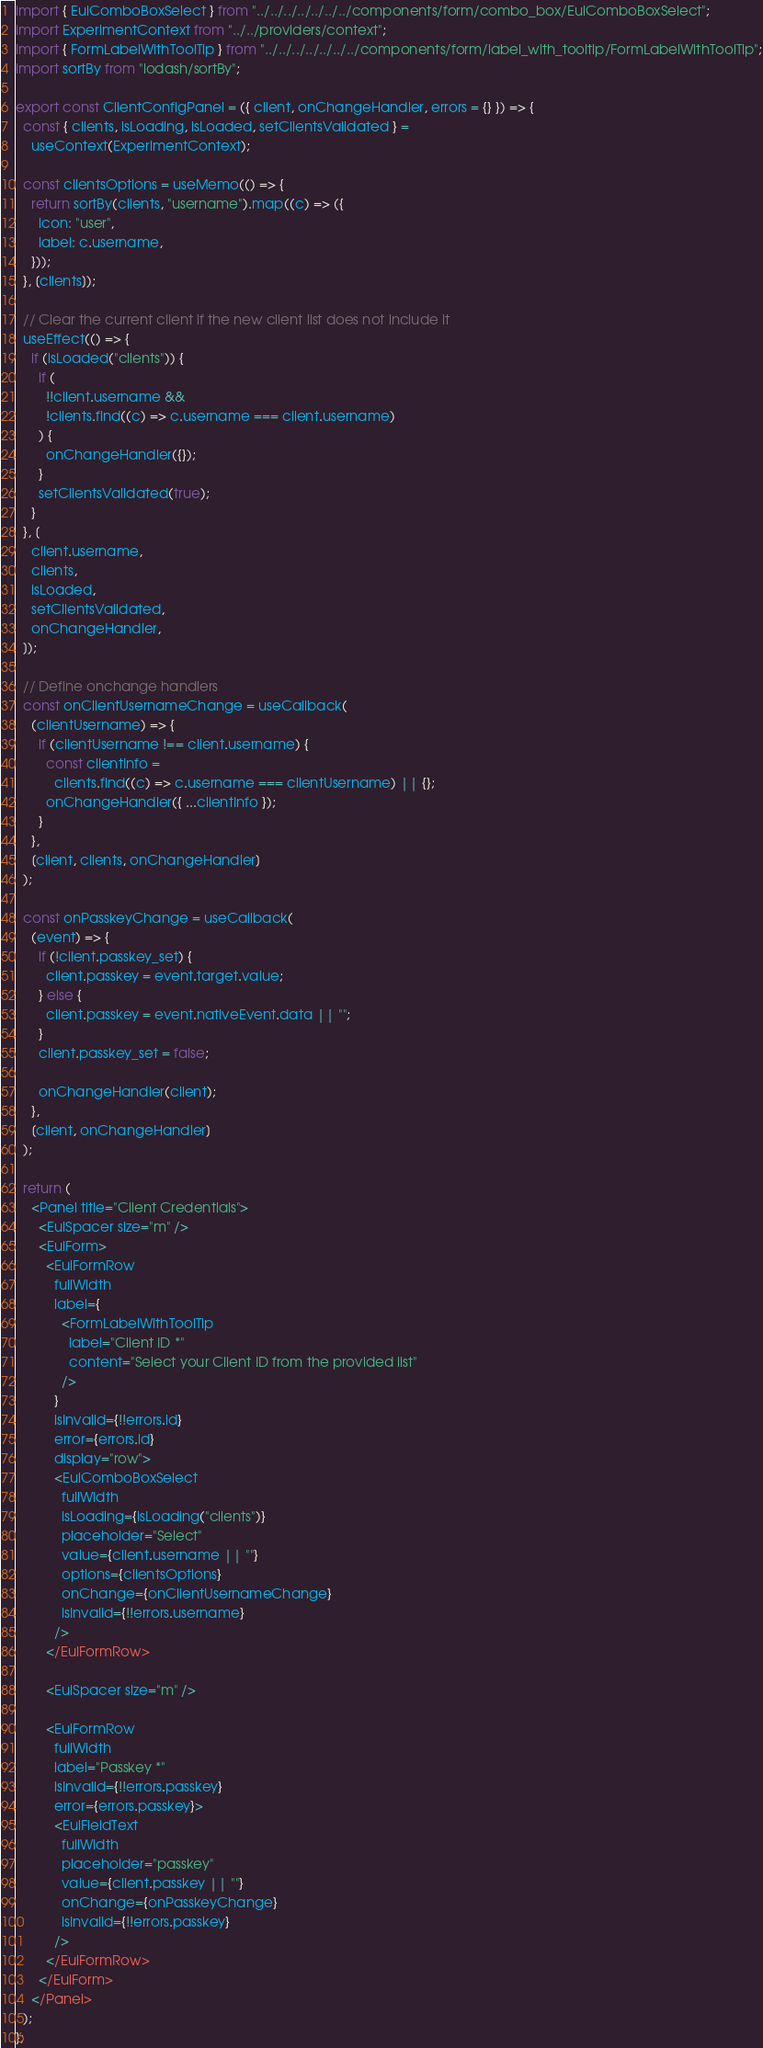<code> <loc_0><loc_0><loc_500><loc_500><_JavaScript_>import { EuiComboBoxSelect } from "../../../../../../../components/form/combo_box/EuiComboBoxSelect";
import ExperimentContext from "../../providers/context";
import { FormLabelWithToolTip } from "../../../../../../../components/form/label_with_tooltip/FormLabelWithToolTip";
import sortBy from "lodash/sortBy";

export const ClientConfigPanel = ({ client, onChangeHandler, errors = {} }) => {
  const { clients, isLoading, isLoaded, setClientsValidated } =
    useContext(ExperimentContext);

  const clientsOptions = useMemo(() => {
    return sortBy(clients, "username").map((c) => ({
      icon: "user",
      label: c.username,
    }));
  }, [clients]);

  // Clear the current client if the new client list does not include it
  useEffect(() => {
    if (isLoaded("clients")) {
      if (
        !!client.username &&
        !clients.find((c) => c.username === client.username)
      ) {
        onChangeHandler({});
      }
      setClientsValidated(true);
    }
  }, [
    client.username,
    clients,
    isLoaded,
    setClientsValidated,
    onChangeHandler,
  ]);

  // Define onchange handlers
  const onClientUsernameChange = useCallback(
    (clientUsername) => {
      if (clientUsername !== client.username) {
        const clientInfo =
          clients.find((c) => c.username === clientUsername) || {};
        onChangeHandler({ ...clientInfo });
      }
    },
    [client, clients, onChangeHandler]
  );

  const onPasskeyChange = useCallback(
    (event) => {
      if (!client.passkey_set) {
        client.passkey = event.target.value;
      } else {
        client.passkey = event.nativeEvent.data || "";
      }
      client.passkey_set = false;

      onChangeHandler(client);
    },
    [client, onChangeHandler]
  );

  return (
    <Panel title="Client Credentials">
      <EuiSpacer size="m" />
      <EuiForm>
        <EuiFormRow
          fullWidth
          label={
            <FormLabelWithToolTip
              label="Client ID *"
              content="Select your Client ID from the provided list"
            />
          }
          isInvalid={!!errors.id}
          error={errors.id}
          display="row">
          <EuiComboBoxSelect
            fullWidth
            isLoading={isLoading("clients")}
            placeholder="Select"
            value={client.username || ""}
            options={clientsOptions}
            onChange={onClientUsernameChange}
            isInvalid={!!errors.username}
          />
        </EuiFormRow>

        <EuiSpacer size="m" />

        <EuiFormRow
          fullWidth
          label="Passkey *"
          isInvalid={!!errors.passkey}
          error={errors.passkey}>
          <EuiFieldText
            fullWidth
            placeholder="passkey"
            value={client.passkey || ""}
            onChange={onPasskeyChange}
            isInvalid={!!errors.passkey}
          />
        </EuiFormRow>
      </EuiForm>
    </Panel>
  );
};
</code> 